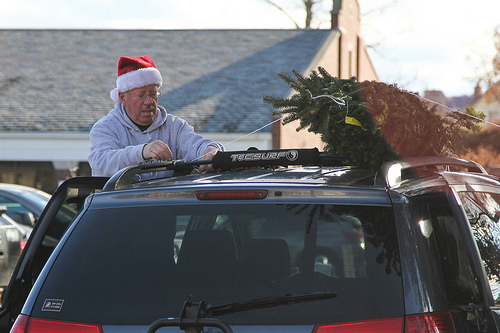<image>
Is there a christmas tree on the luggage rack? Yes. Looking at the image, I can see the christmas tree is positioned on top of the luggage rack, with the luggage rack providing support. 